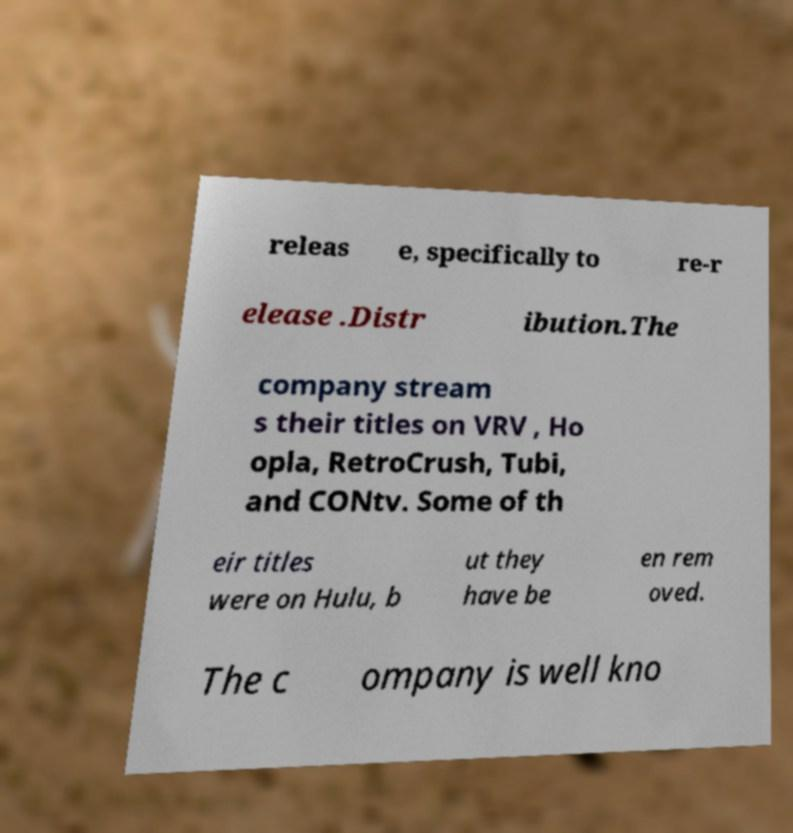What messages or text are displayed in this image? I need them in a readable, typed format. releas e, specifically to re-r elease .Distr ibution.The company stream s their titles on VRV , Ho opla, RetroCrush, Tubi, and CONtv. Some of th eir titles were on Hulu, b ut they have be en rem oved. The c ompany is well kno 